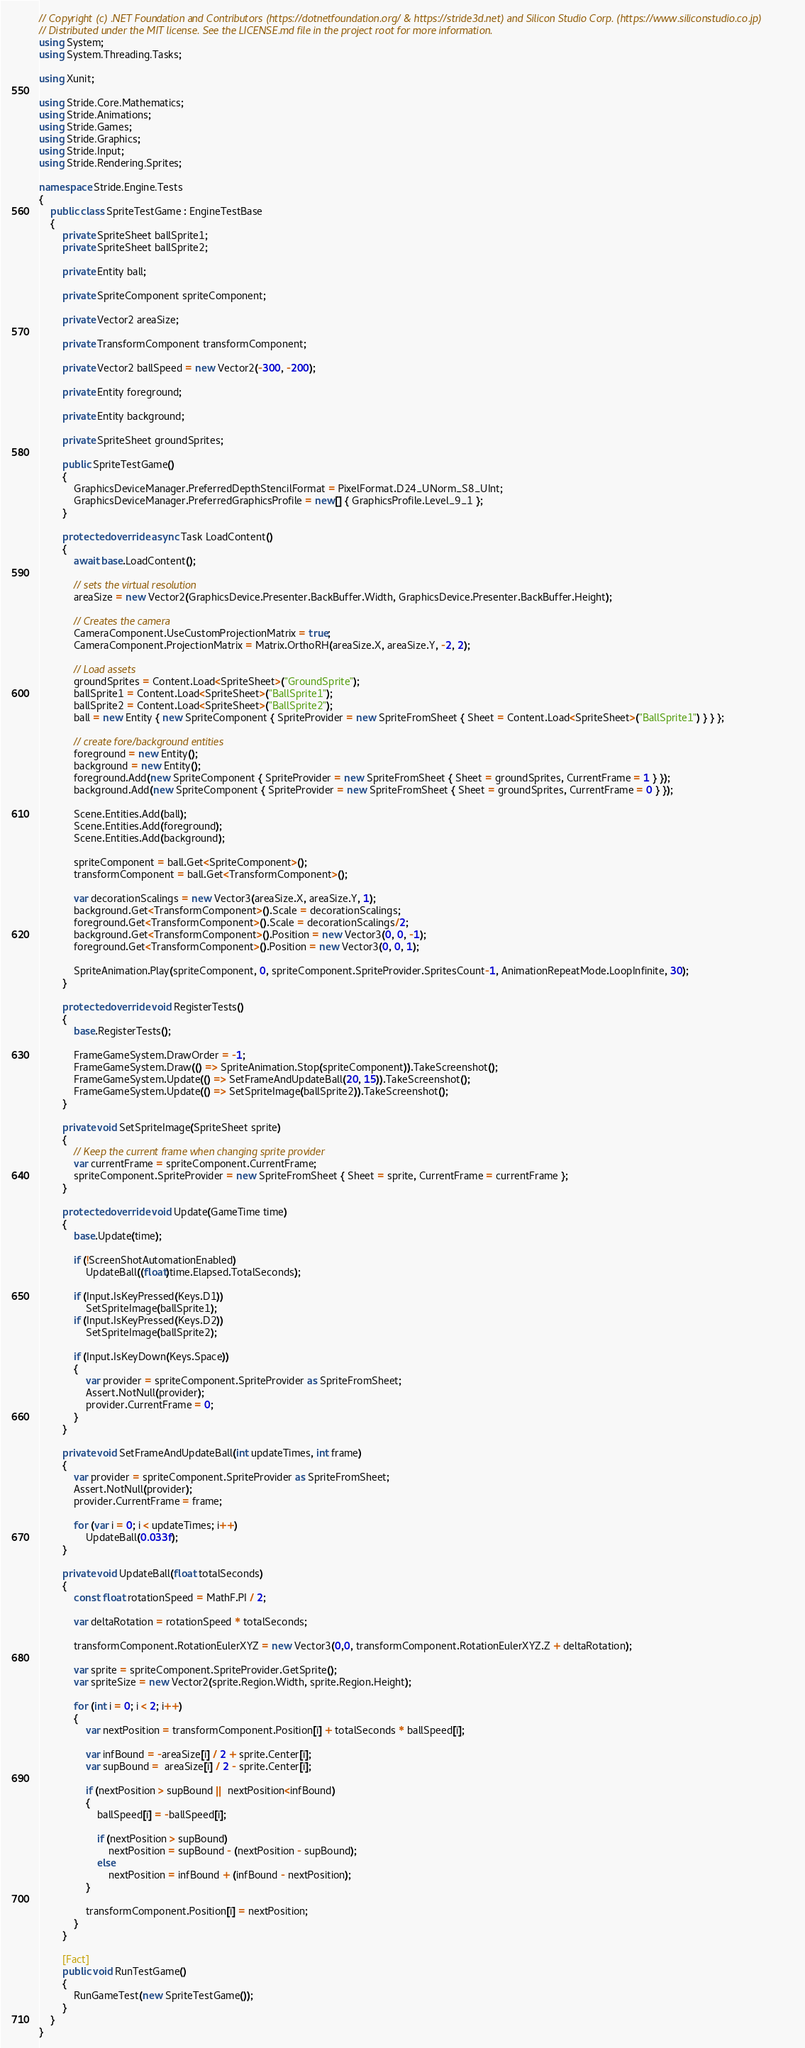Convert code to text. <code><loc_0><loc_0><loc_500><loc_500><_C#_>// Copyright (c) .NET Foundation and Contributors (https://dotnetfoundation.org/ & https://stride3d.net) and Silicon Studio Corp. (https://www.siliconstudio.co.jp)
// Distributed under the MIT license. See the LICENSE.md file in the project root for more information.
using System;
using System.Threading.Tasks;

using Xunit;

using Stride.Core.Mathematics;
using Stride.Animations;
using Stride.Games;
using Stride.Graphics;
using Stride.Input;
using Stride.Rendering.Sprites;

namespace Stride.Engine.Tests
{
    public class SpriteTestGame : EngineTestBase
    {
        private SpriteSheet ballSprite1;
        private SpriteSheet ballSprite2;

        private Entity ball;

        private SpriteComponent spriteComponent;

        private Vector2 areaSize;

        private TransformComponent transformComponent;

        private Vector2 ballSpeed = new Vector2(-300, -200);

        private Entity foreground;

        private Entity background;

        private SpriteSheet groundSprites;

        public SpriteTestGame()
        {
            GraphicsDeviceManager.PreferredDepthStencilFormat = PixelFormat.D24_UNorm_S8_UInt;
            GraphicsDeviceManager.PreferredGraphicsProfile = new[] { GraphicsProfile.Level_9_1 };
        }

        protected override async Task LoadContent()
        {
            await base.LoadContent();
            
            // sets the virtual resolution
            areaSize = new Vector2(GraphicsDevice.Presenter.BackBuffer.Width, GraphicsDevice.Presenter.BackBuffer.Height);

            // Creates the camera
            CameraComponent.UseCustomProjectionMatrix = true;
            CameraComponent.ProjectionMatrix = Matrix.OrthoRH(areaSize.X, areaSize.Y, -2, 2);

            // Load assets
            groundSprites = Content.Load<SpriteSheet>("GroundSprite");
            ballSprite1 = Content.Load<SpriteSheet>("BallSprite1");
            ballSprite2 = Content.Load<SpriteSheet>("BallSprite2");
            ball = new Entity { new SpriteComponent { SpriteProvider = new SpriteFromSheet { Sheet = Content.Load<SpriteSheet>("BallSprite1") } } };

            // create fore/background entities
            foreground = new Entity();
            background = new Entity();
            foreground.Add(new SpriteComponent { SpriteProvider = new SpriteFromSheet { Sheet = groundSprites, CurrentFrame = 1 } });
            background.Add(new SpriteComponent { SpriteProvider = new SpriteFromSheet { Sheet = groundSprites, CurrentFrame = 0 } });

            Scene.Entities.Add(ball);
            Scene.Entities.Add(foreground);
            Scene.Entities.Add(background);

            spriteComponent = ball.Get<SpriteComponent>();
            transformComponent = ball.Get<TransformComponent>();

            var decorationScalings = new Vector3(areaSize.X, areaSize.Y, 1);
            background.Get<TransformComponent>().Scale = decorationScalings;
            foreground.Get<TransformComponent>().Scale = decorationScalings/2;
            background.Get<TransformComponent>().Position = new Vector3(0, 0, -1);
            foreground.Get<TransformComponent>().Position = new Vector3(0, 0, 1);

            SpriteAnimation.Play(spriteComponent, 0, spriteComponent.SpriteProvider.SpritesCount-1, AnimationRepeatMode.LoopInfinite, 30);
        }

        protected override void RegisterTests()
        {
            base.RegisterTests();

            FrameGameSystem.DrawOrder = -1;
            FrameGameSystem.Draw(() => SpriteAnimation.Stop(spriteComponent)).TakeScreenshot();
            FrameGameSystem.Update(() => SetFrameAndUpdateBall(20, 15)).TakeScreenshot();
            FrameGameSystem.Update(() => SetSpriteImage(ballSprite2)).TakeScreenshot();
        }

        private void SetSpriteImage(SpriteSheet sprite)
        {
            // Keep the current frame when changing sprite provider
            var currentFrame = spriteComponent.CurrentFrame;
            spriteComponent.SpriteProvider = new SpriteFromSheet { Sheet = sprite, CurrentFrame = currentFrame };
        }

        protected override void Update(GameTime time)
        {
            base.Update(time);

            if (!ScreenShotAutomationEnabled)
                UpdateBall((float)time.Elapsed.TotalSeconds);

            if (Input.IsKeyPressed(Keys.D1))
                SetSpriteImage(ballSprite1);
            if (Input.IsKeyPressed(Keys.D2))
                SetSpriteImage(ballSprite2);

            if (Input.IsKeyDown(Keys.Space))
            {
                var provider = spriteComponent.SpriteProvider as SpriteFromSheet;
                Assert.NotNull(provider);
                provider.CurrentFrame = 0;
            }
        }

        private void SetFrameAndUpdateBall(int updateTimes, int frame)
        {
            var provider = spriteComponent.SpriteProvider as SpriteFromSheet;
            Assert.NotNull(provider);
            provider.CurrentFrame = frame;

            for (var i = 0; i < updateTimes; i++)
                UpdateBall(0.033f);
        }

        private void UpdateBall(float totalSeconds)
        {
            const float rotationSpeed = MathF.PI / 2;

            var deltaRotation = rotationSpeed * totalSeconds;

            transformComponent.RotationEulerXYZ = new Vector3(0,0, transformComponent.RotationEulerXYZ.Z + deltaRotation);

            var sprite = spriteComponent.SpriteProvider.GetSprite();
            var spriteSize = new Vector2(sprite.Region.Width, sprite.Region.Height);

            for (int i = 0; i < 2; i++)
            {
                var nextPosition = transformComponent.Position[i] + totalSeconds * ballSpeed[i];

                var infBound = -areaSize[i] / 2 + sprite.Center[i];
                var supBound =  areaSize[i] / 2 - sprite.Center[i];

                if (nextPosition > supBound || nextPosition<infBound)
                {
                    ballSpeed[i] = -ballSpeed[i];

                    if (nextPosition > supBound)
                        nextPosition = supBound - (nextPosition - supBound);
                    else
                        nextPosition = infBound + (infBound - nextPosition);
                }

                transformComponent.Position[i] = nextPosition;
            }
        }

        [Fact]
        public void RunTestGame()
        {
            RunGameTest(new SpriteTestGame());
        }
    }
}
</code> 